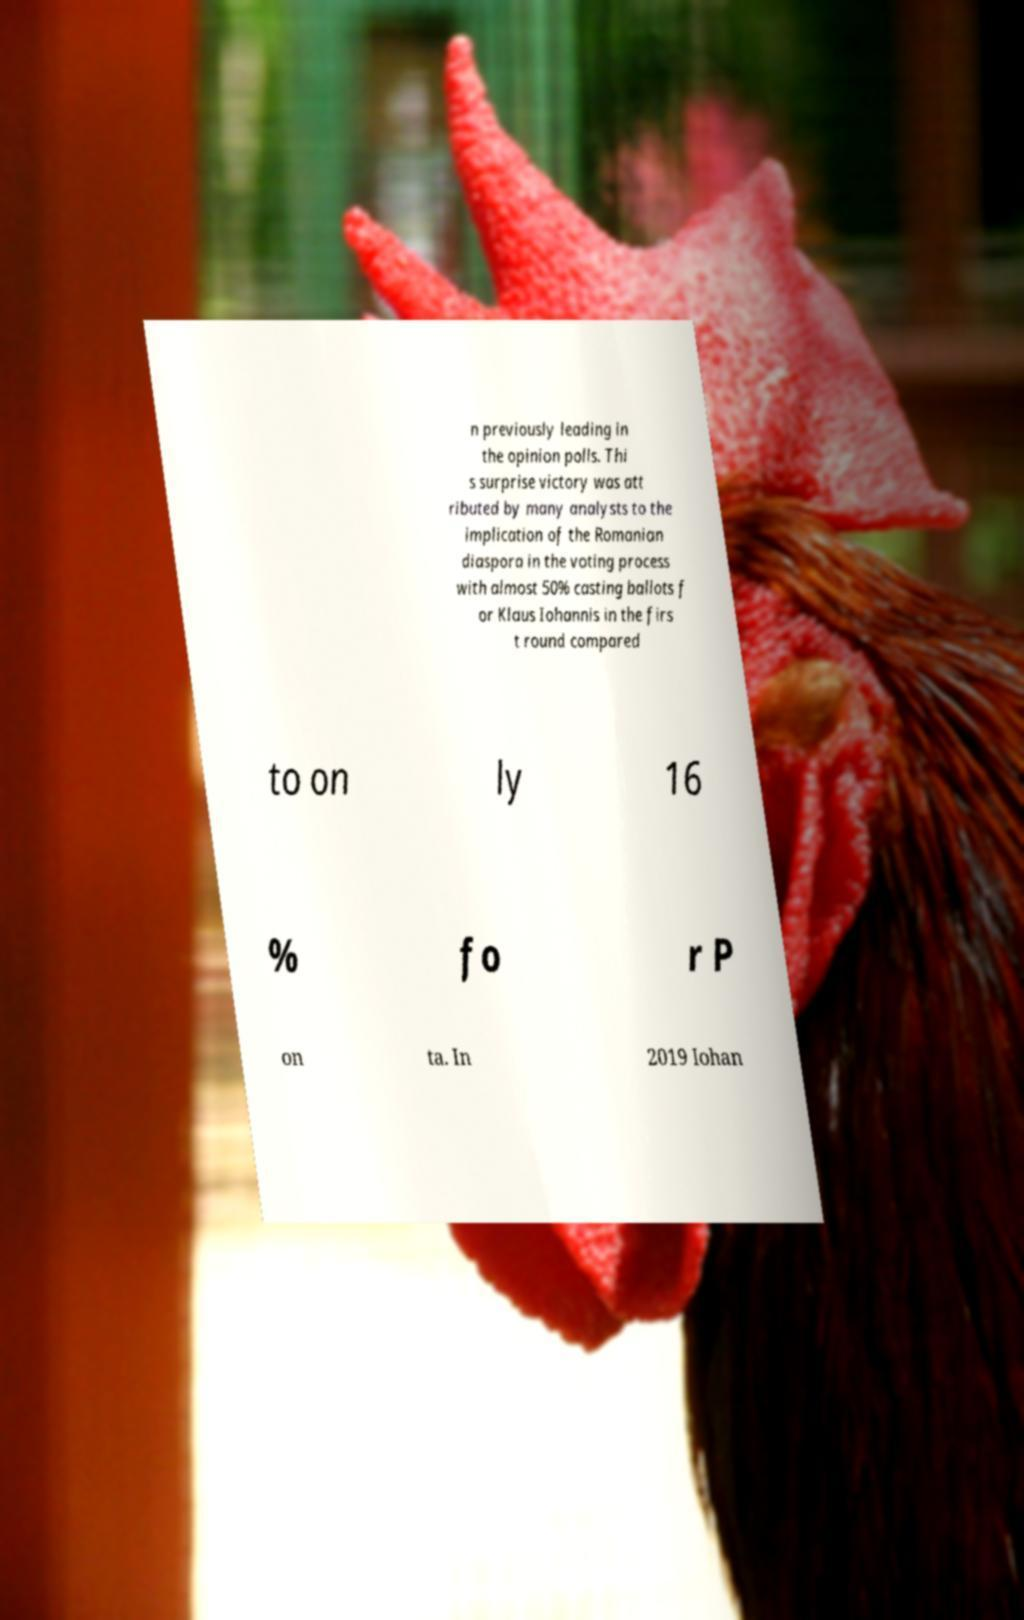There's text embedded in this image that I need extracted. Can you transcribe it verbatim? n previously leading in the opinion polls. Thi s surprise victory was att ributed by many analysts to the implication of the Romanian diaspora in the voting process with almost 50% casting ballots f or Klaus Iohannis in the firs t round compared to on ly 16 % fo r P on ta. In 2019 Iohan 